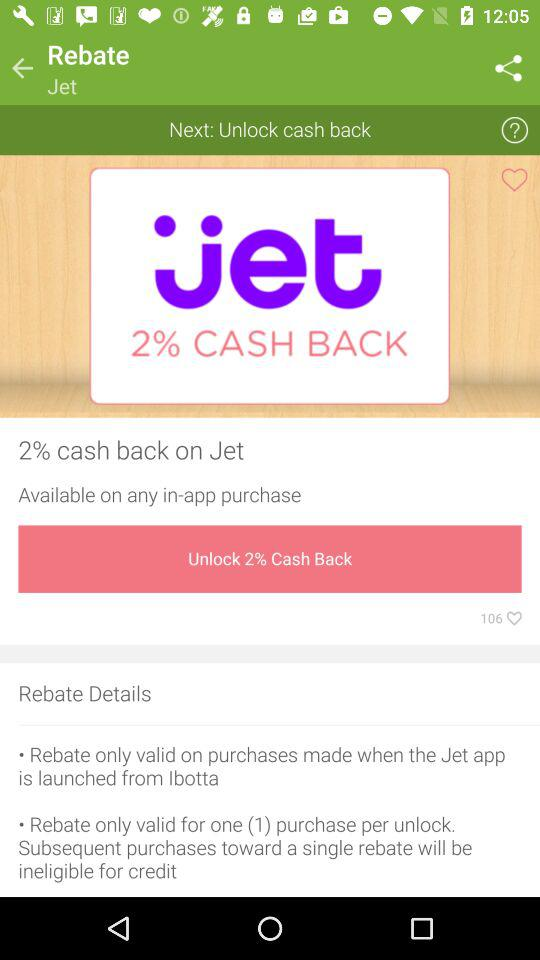How many purchases are allowed per unlock?
Answer the question using a single word or phrase. 1 